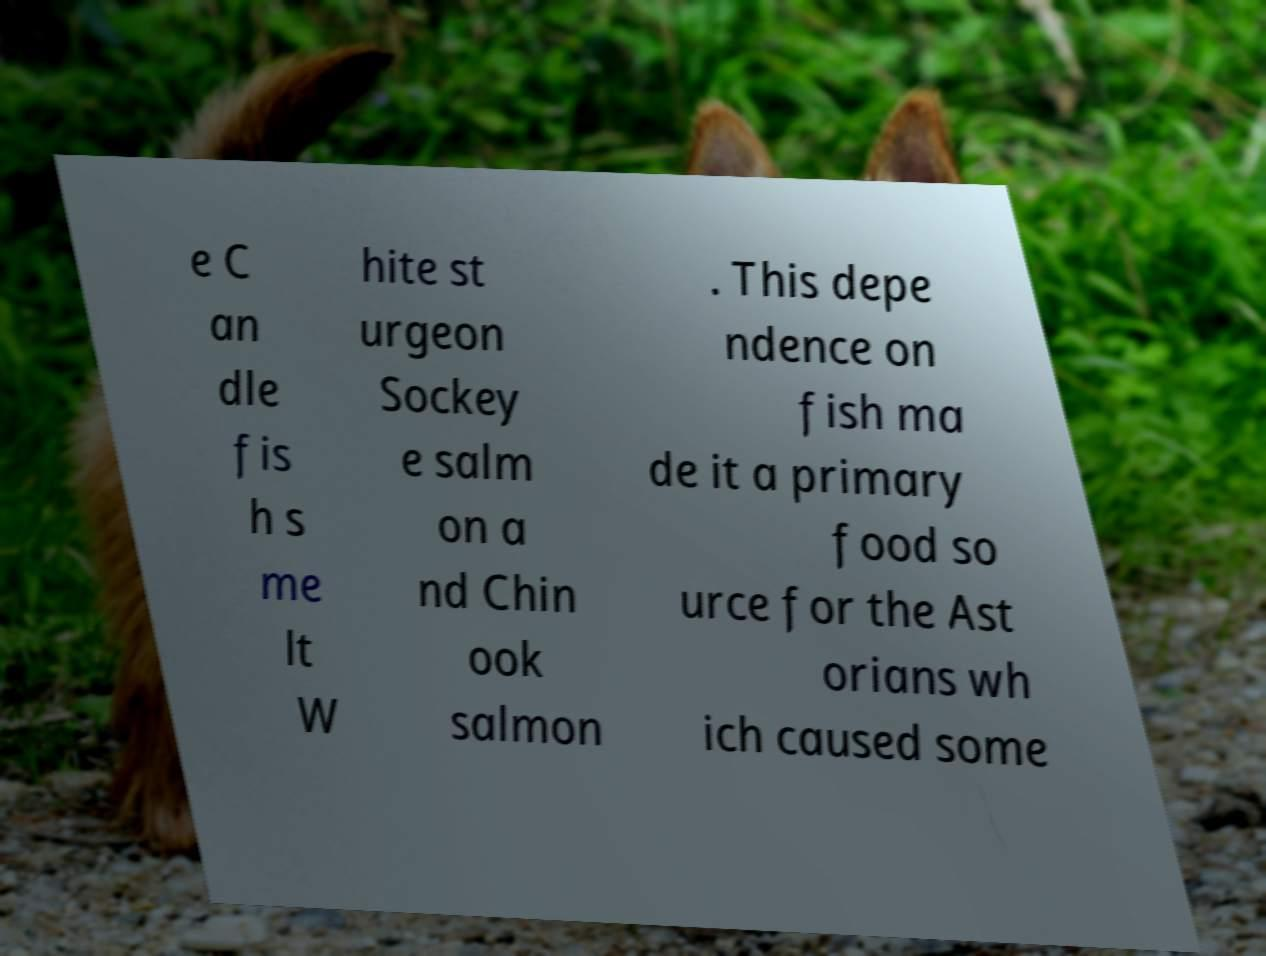Can you accurately transcribe the text from the provided image for me? e C an dle fis h s me lt W hite st urgeon Sockey e salm on a nd Chin ook salmon . This depe ndence on fish ma de it a primary food so urce for the Ast orians wh ich caused some 